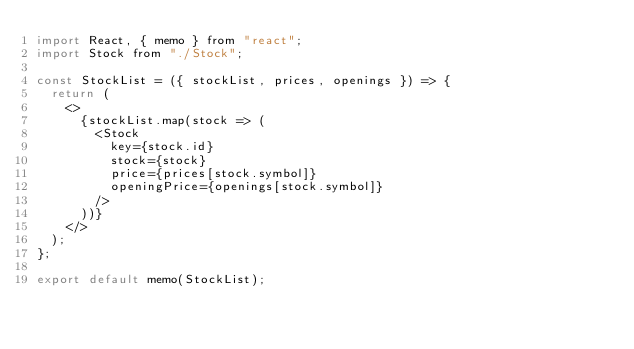<code> <loc_0><loc_0><loc_500><loc_500><_JavaScript_>import React, { memo } from "react";
import Stock from "./Stock";

const StockList = ({ stockList, prices, openings }) => {
  return (
    <>
      {stockList.map(stock => (
        <Stock
          key={stock.id}
          stock={stock}
          price={prices[stock.symbol]}
          openingPrice={openings[stock.symbol]}
        />
      ))}
    </>
  );
};

export default memo(StockList);
</code> 